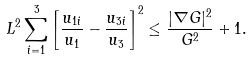Convert formula to latex. <formula><loc_0><loc_0><loc_500><loc_500>L ^ { 2 } \sum _ { i = 1 } ^ { 3 } \left [ \frac { u _ { 1 i } } { u _ { 1 } } - \frac { u _ { 3 i } } { u _ { 3 } } \right ] ^ { 2 } \leq \frac { | \nabla G | ^ { 2 } } { G ^ { 2 } } + 1 .</formula> 